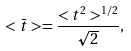<formula> <loc_0><loc_0><loc_500><loc_500>< \bar { t } > = \frac { < t ^ { 2 } > ^ { 1 / 2 } } { \sqrt { 2 } } ,</formula> 